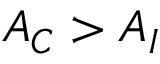Convert formula to latex. <formula><loc_0><loc_0><loc_500><loc_500>A _ { C } > A _ { I }</formula> 